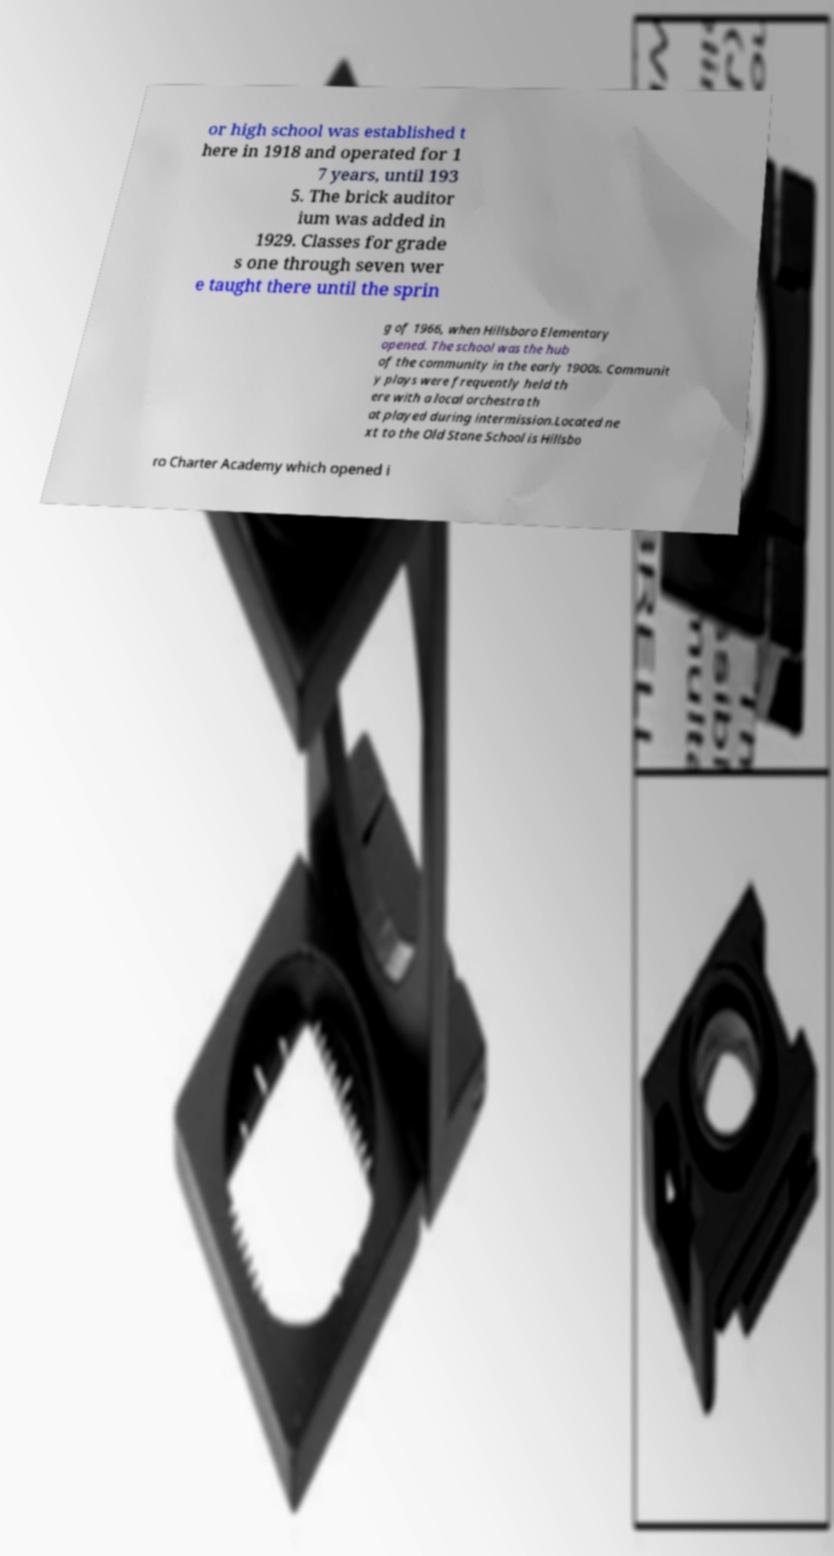What messages or text are displayed in this image? I need them in a readable, typed format. or high school was established t here in 1918 and operated for 1 7 years, until 193 5. The brick auditor ium was added in 1929. Classes for grade s one through seven wer e taught there until the sprin g of 1966, when Hillsboro Elementary opened. The school was the hub of the community in the early 1900s. Communit y plays were frequently held th ere with a local orchestra th at played during intermission.Located ne xt to the Old Stone School is Hillsbo ro Charter Academy which opened i 